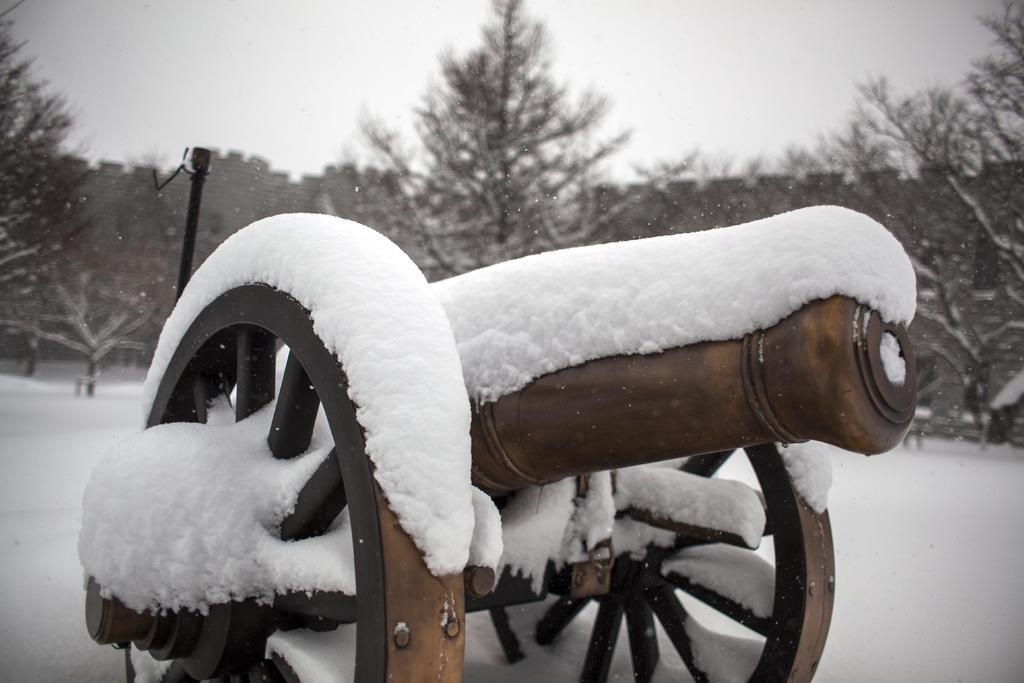What object in the picture is covered with snow? The weapon in the picture is covered with snow. What is the condition of the ground in the image? The floor in the image is covered with snow. What can be seen in the backdrop of the image? There is a pole, trees, and a wall in the backdrop of the image. What is the weather like in the image? The sky is clear in the image, and there is snow on the ground, suggesting a cold and likely sunny day. What type of meat is hanging from the pole in the image? There is no meat hanging from the pole in the image; it is a pole in the backdrop of the picture. Is there a bridge visible in the image? No, there is no bridge present in the image. 